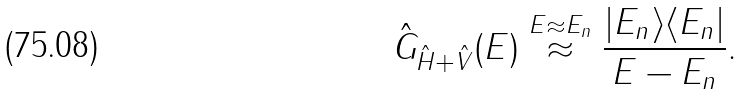Convert formula to latex. <formula><loc_0><loc_0><loc_500><loc_500>\hat { G } _ { \hat { H } + \hat { V } } ( E ) \stackrel { E \approx E _ { n } } { \approx } \frac { | E _ { n } \rangle \langle E _ { n } | } { E - E _ { n } } .</formula> 